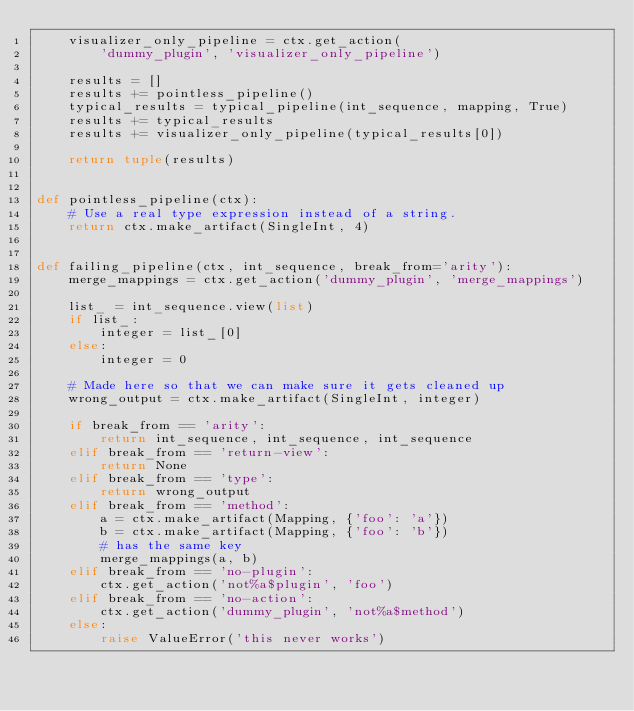Convert code to text. <code><loc_0><loc_0><loc_500><loc_500><_Python_>    visualizer_only_pipeline = ctx.get_action(
        'dummy_plugin', 'visualizer_only_pipeline')

    results = []
    results += pointless_pipeline()
    typical_results = typical_pipeline(int_sequence, mapping, True)
    results += typical_results
    results += visualizer_only_pipeline(typical_results[0])

    return tuple(results)


def pointless_pipeline(ctx):
    # Use a real type expression instead of a string.
    return ctx.make_artifact(SingleInt, 4)


def failing_pipeline(ctx, int_sequence, break_from='arity'):
    merge_mappings = ctx.get_action('dummy_plugin', 'merge_mappings')

    list_ = int_sequence.view(list)
    if list_:
        integer = list_[0]
    else:
        integer = 0

    # Made here so that we can make sure it gets cleaned up
    wrong_output = ctx.make_artifact(SingleInt, integer)

    if break_from == 'arity':
        return int_sequence, int_sequence, int_sequence
    elif break_from == 'return-view':
        return None
    elif break_from == 'type':
        return wrong_output
    elif break_from == 'method':
        a = ctx.make_artifact(Mapping, {'foo': 'a'})
        b = ctx.make_artifact(Mapping, {'foo': 'b'})
        # has the same key
        merge_mappings(a, b)
    elif break_from == 'no-plugin':
        ctx.get_action('not%a$plugin', 'foo')
    elif break_from == 'no-action':
        ctx.get_action('dummy_plugin', 'not%a$method')
    else:
        raise ValueError('this never works')
</code> 